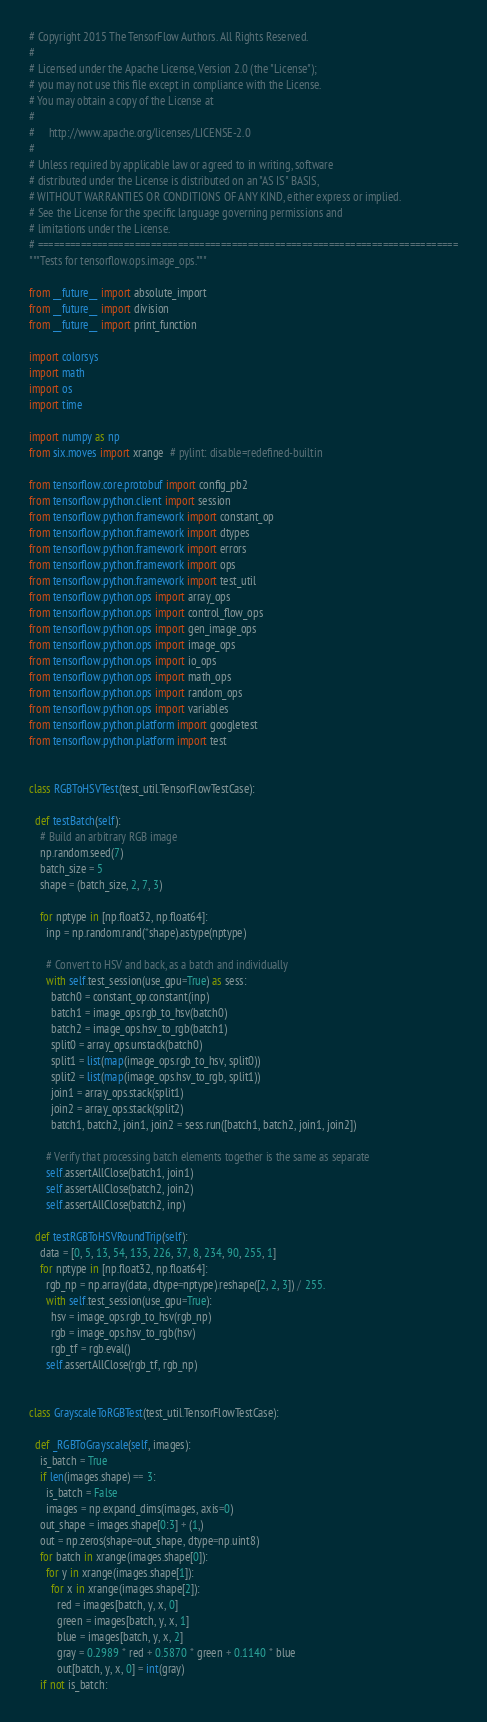<code> <loc_0><loc_0><loc_500><loc_500><_Python_># Copyright 2015 The TensorFlow Authors. All Rights Reserved.
#
# Licensed under the Apache License, Version 2.0 (the "License");
# you may not use this file except in compliance with the License.
# You may obtain a copy of the License at
#
#     http://www.apache.org/licenses/LICENSE-2.0
#
# Unless required by applicable law or agreed to in writing, software
# distributed under the License is distributed on an "AS IS" BASIS,
# WITHOUT WARRANTIES OR CONDITIONS OF ANY KIND, either express or implied.
# See the License for the specific language governing permissions and
# limitations under the License.
# ==============================================================================
"""Tests for tensorflow.ops.image_ops."""

from __future__ import absolute_import
from __future__ import division
from __future__ import print_function

import colorsys
import math
import os
import time

import numpy as np
from six.moves import xrange  # pylint: disable=redefined-builtin

from tensorflow.core.protobuf import config_pb2
from tensorflow.python.client import session
from tensorflow.python.framework import constant_op
from tensorflow.python.framework import dtypes
from tensorflow.python.framework import errors
from tensorflow.python.framework import ops
from tensorflow.python.framework import test_util
from tensorflow.python.ops import array_ops
from tensorflow.python.ops import control_flow_ops
from tensorflow.python.ops import gen_image_ops
from tensorflow.python.ops import image_ops
from tensorflow.python.ops import io_ops
from tensorflow.python.ops import math_ops
from tensorflow.python.ops import random_ops
from tensorflow.python.ops import variables
from tensorflow.python.platform import googletest
from tensorflow.python.platform import test


class RGBToHSVTest(test_util.TensorFlowTestCase):

  def testBatch(self):
    # Build an arbitrary RGB image
    np.random.seed(7)
    batch_size = 5
    shape = (batch_size, 2, 7, 3)

    for nptype in [np.float32, np.float64]:
      inp = np.random.rand(*shape).astype(nptype)

      # Convert to HSV and back, as a batch and individually
      with self.test_session(use_gpu=True) as sess:
        batch0 = constant_op.constant(inp)
        batch1 = image_ops.rgb_to_hsv(batch0)
        batch2 = image_ops.hsv_to_rgb(batch1)
        split0 = array_ops.unstack(batch0)
        split1 = list(map(image_ops.rgb_to_hsv, split0))
        split2 = list(map(image_ops.hsv_to_rgb, split1))
        join1 = array_ops.stack(split1)
        join2 = array_ops.stack(split2)
        batch1, batch2, join1, join2 = sess.run([batch1, batch2, join1, join2])

      # Verify that processing batch elements together is the same as separate
      self.assertAllClose(batch1, join1)
      self.assertAllClose(batch2, join2)
      self.assertAllClose(batch2, inp)

  def testRGBToHSVRoundTrip(self):
    data = [0, 5, 13, 54, 135, 226, 37, 8, 234, 90, 255, 1]
    for nptype in [np.float32, np.float64]:
      rgb_np = np.array(data, dtype=nptype).reshape([2, 2, 3]) / 255.
      with self.test_session(use_gpu=True):
        hsv = image_ops.rgb_to_hsv(rgb_np)
        rgb = image_ops.hsv_to_rgb(hsv)
        rgb_tf = rgb.eval()
      self.assertAllClose(rgb_tf, rgb_np)


class GrayscaleToRGBTest(test_util.TensorFlowTestCase):

  def _RGBToGrayscale(self, images):
    is_batch = True
    if len(images.shape) == 3:
      is_batch = False
      images = np.expand_dims(images, axis=0)
    out_shape = images.shape[0:3] + (1,)
    out = np.zeros(shape=out_shape, dtype=np.uint8)
    for batch in xrange(images.shape[0]):
      for y in xrange(images.shape[1]):
        for x in xrange(images.shape[2]):
          red = images[batch, y, x, 0]
          green = images[batch, y, x, 1]
          blue = images[batch, y, x, 2]
          gray = 0.2989 * red + 0.5870 * green + 0.1140 * blue
          out[batch, y, x, 0] = int(gray)
    if not is_batch:</code> 